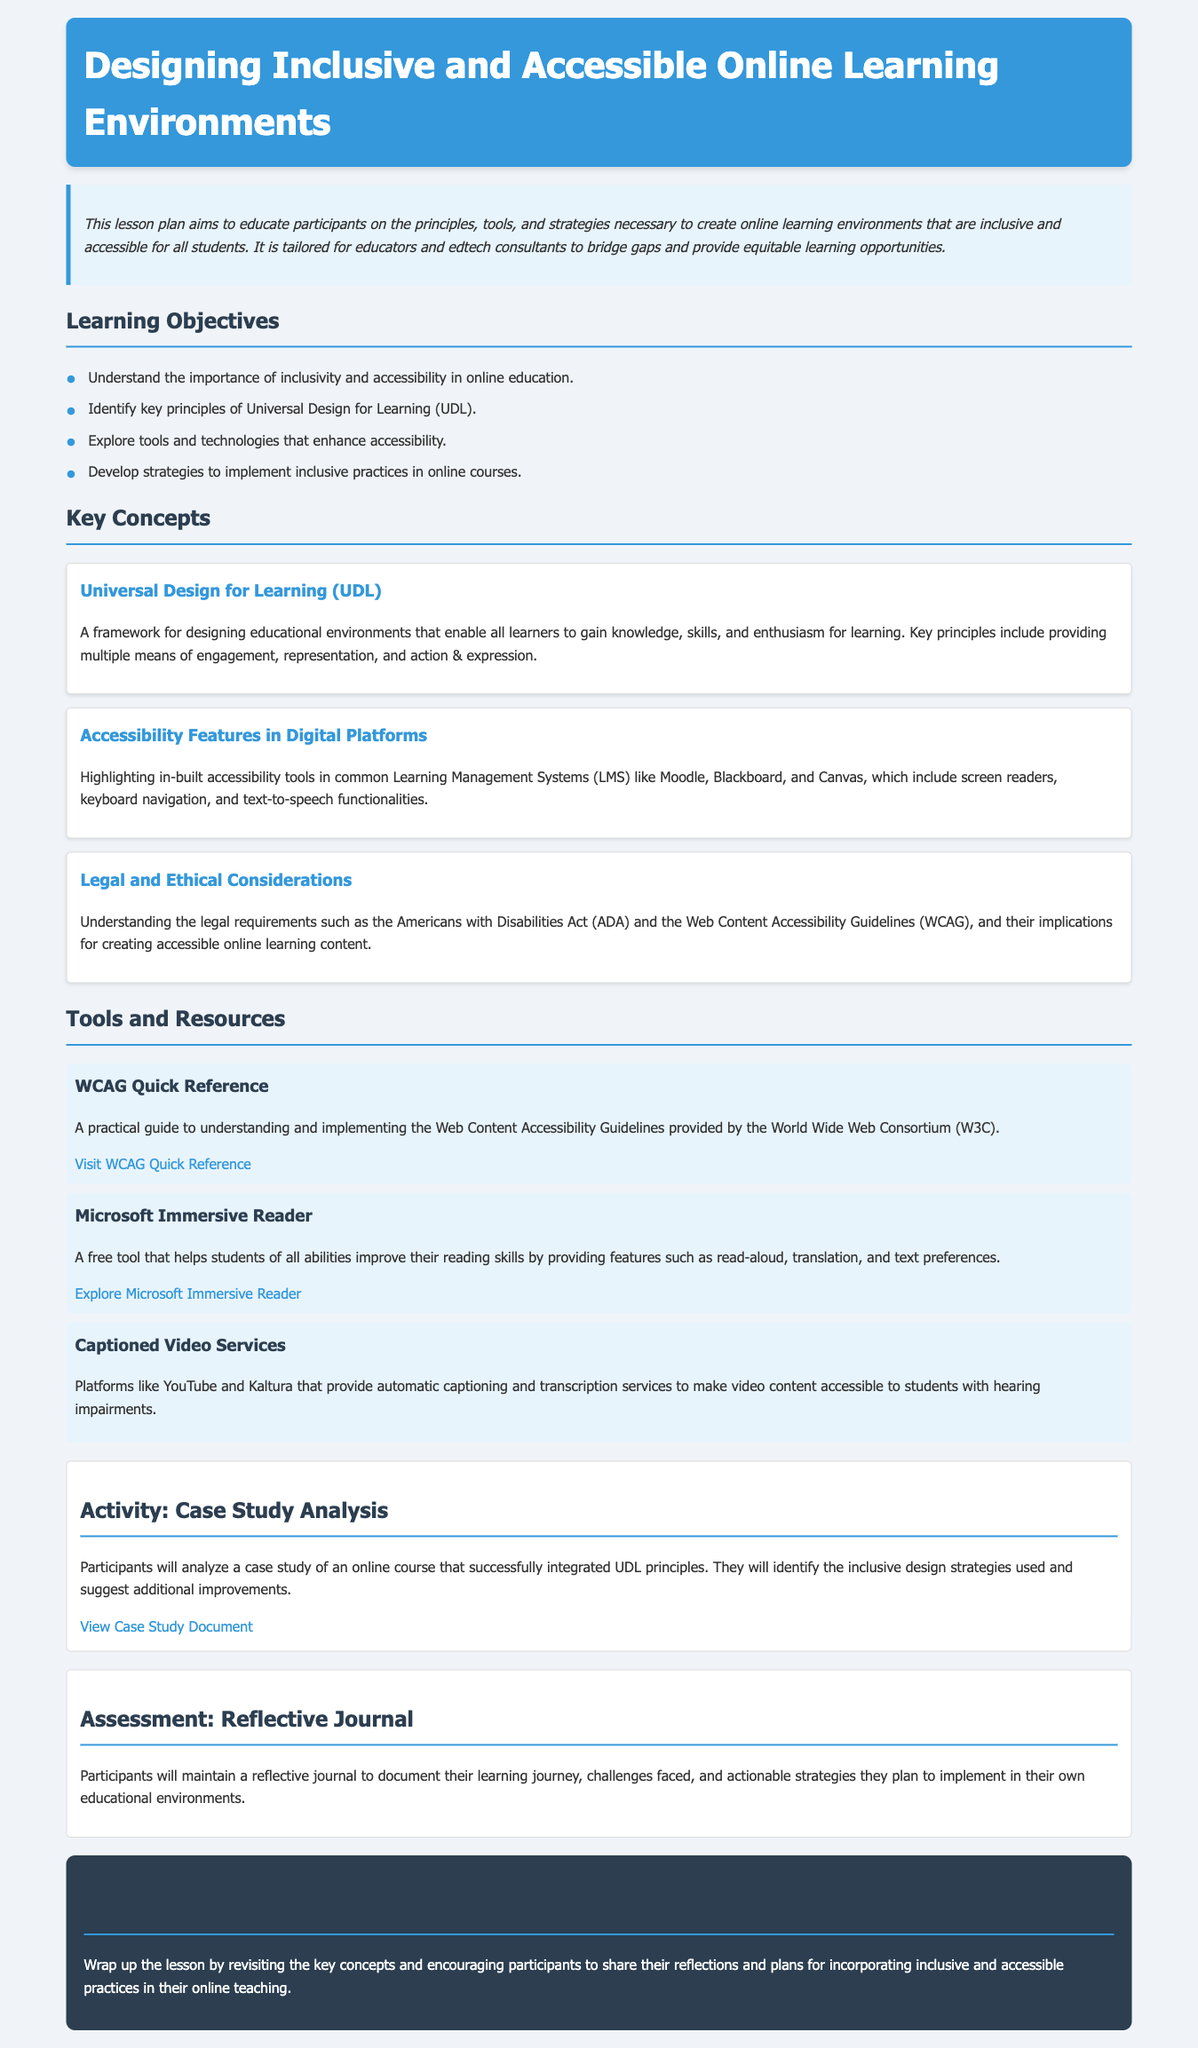what is the main topic of the lesson plan? The title of the document indicates the primary subject being taught, which focuses on creating environments that include and meet the needs of all learners.
Answer: Designing Inclusive and Accessible Online Learning Environments who is the target audience for this lesson plan? The summary specifies that the lesson plan is tailored for those who work in education, particularly focusing on educators and edtech consultants.
Answer: Educators and edtech consultants what framework is highlighted for designing educational environments? The document introduces a specific educational framework after elaborating on inclusivity and accessibility principles, which guides the design of learning experiences.
Answer: Universal Design for Learning (UDL) which legal requirement is mentioned in the document? The document points to a specific legal act that governs accessibility standards in educational contexts.
Answer: Americans with Disabilities Act (ADA) what tool is provided for reading improvement? One of the listed tools aims at enhancing reading skills, mentioning its support for various types of learners.
Answer: Microsoft Immersive Reader what is the main activity outlined in the lesson plan? The activity section describes an engagement that involves analyzing a specific scenario related to UDL principles, requiring critical thinking and application of concepts learned.
Answer: Case Study Analysis how will participants document their learning journey? The assessment portion of the lesson plan describes a reflective method for participants to track their learning experiences and insights gained throughout the course.
Answer: Reflective Journal how many main learning objectives are outlined in the document? The section detailing learning objectives lists individual aims that participants should achieve, summing them up in a clear and structured manner.
Answer: Four what type of content does the "Captioned Video Services" section refer to? This specific part of the document discusses mechanisms used to enhance video accessibility, emphasizing the support for students with certain disabilities.
Answer: Video content what should participants do at the conclusion of the lesson? The conclusion prompts actions for participants, encouraging them to share insights gained through the learning process regarding inclusivity practices.
Answer: Share reflections and plans 